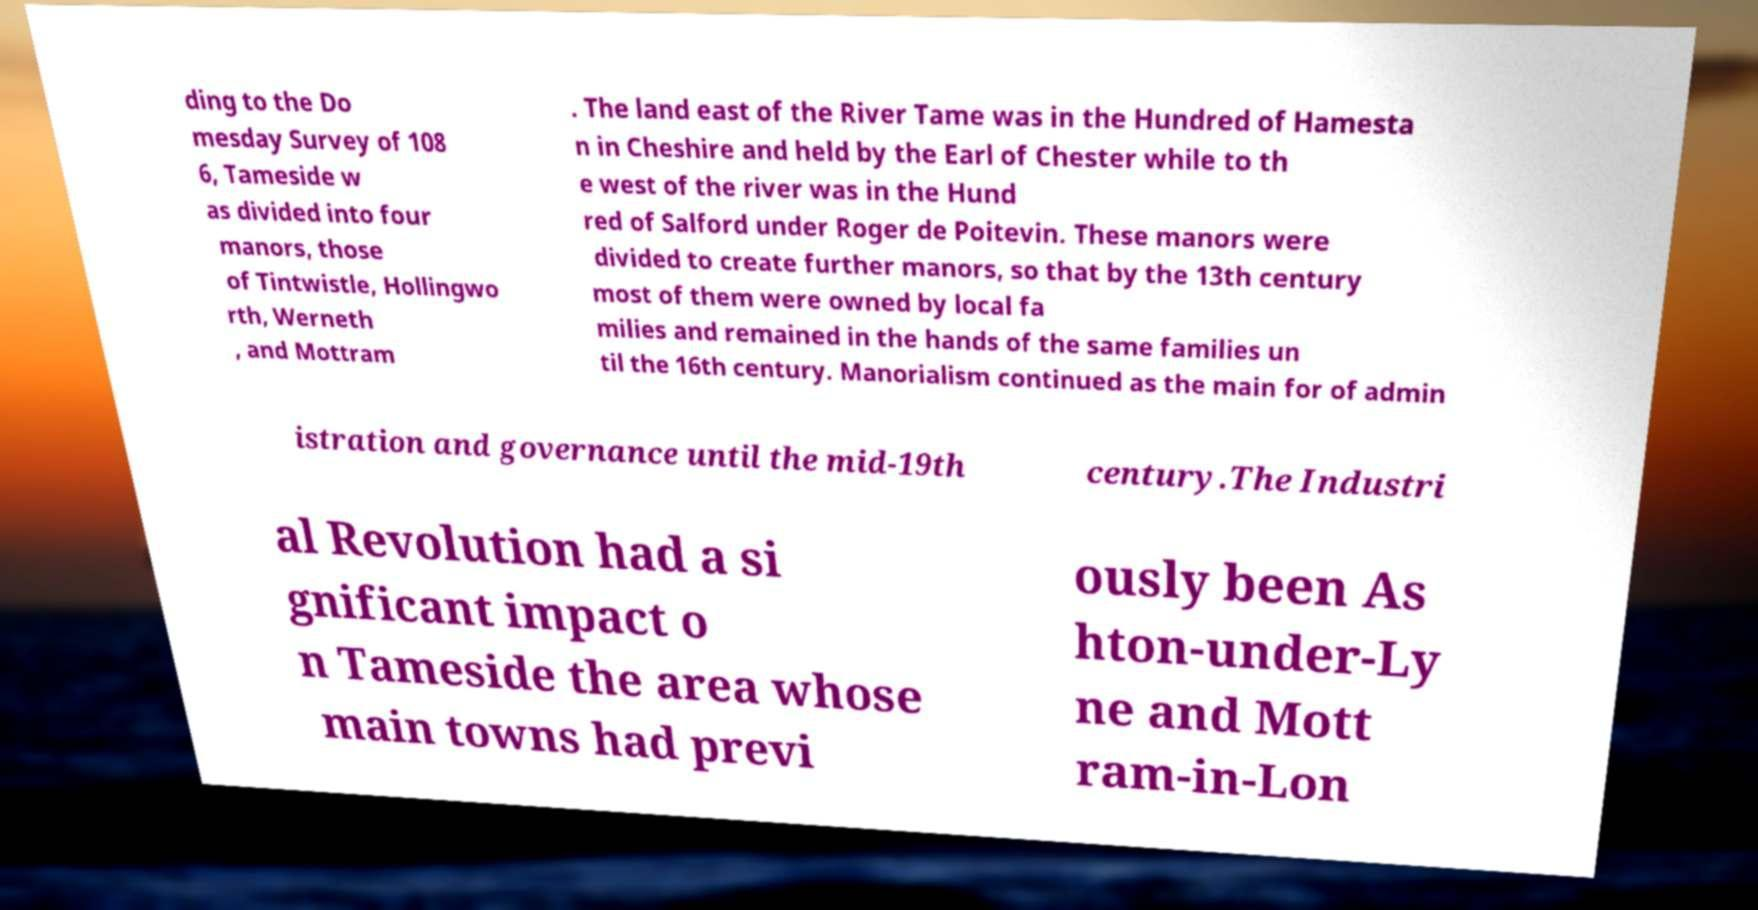Please identify and transcribe the text found in this image. ding to the Do mesday Survey of 108 6, Tameside w as divided into four manors, those of Tintwistle, Hollingwo rth, Werneth , and Mottram . The land east of the River Tame was in the Hundred of Hamesta n in Cheshire and held by the Earl of Chester while to th e west of the river was in the Hund red of Salford under Roger de Poitevin. These manors were divided to create further manors, so that by the 13th century most of them were owned by local fa milies and remained in the hands of the same families un til the 16th century. Manorialism continued as the main for of admin istration and governance until the mid-19th century.The Industri al Revolution had a si gnificant impact o n Tameside the area whose main towns had previ ously been As hton-under-Ly ne and Mott ram-in-Lon 